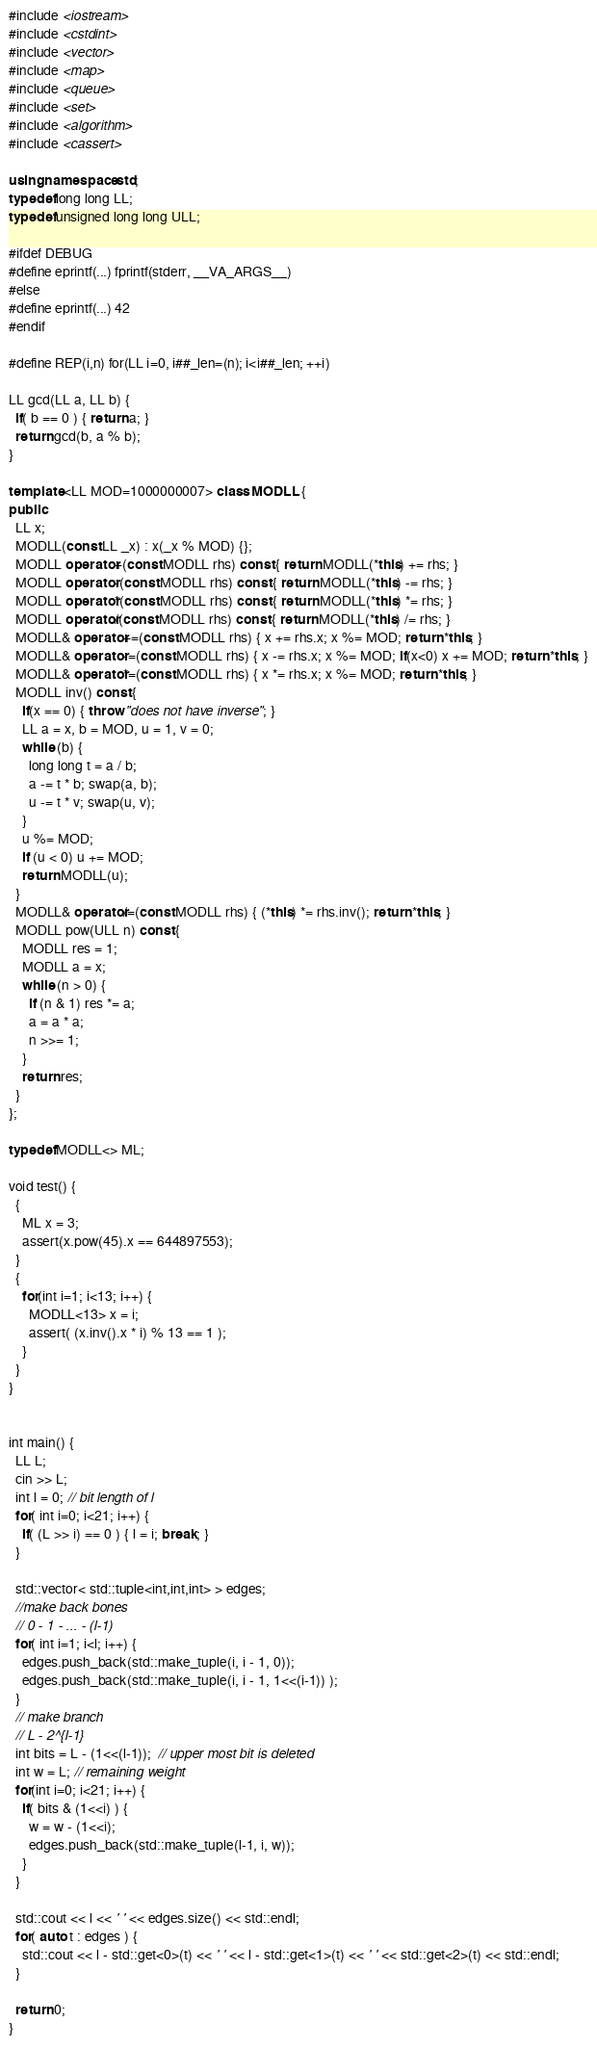<code> <loc_0><loc_0><loc_500><loc_500><_C++_>#include <iostream>
#include <cstdint>
#include <vector>
#include <map>
#include <queue>
#include <set>
#include <algorithm>
#include <cassert>

using namespace std;
typedef long long LL;
typedef unsigned long long ULL;

#ifdef DEBUG
#define eprintf(...) fprintf(stderr, __VA_ARGS__)
#else
#define eprintf(...) 42
#endif

#define REP(i,n) for(LL i=0, i##_len=(n); i<i##_len; ++i)

LL gcd(LL a, LL b) {
  if( b == 0 ) { return a; }
  return gcd(b, a % b);
}

template <LL MOD=1000000007> class MODLL {
public:
  LL x;
  MODLL(const LL _x) : x(_x % MOD) {};
  MODLL operator+(const MODLL rhs) const { return MODLL(*this) += rhs; }
  MODLL operator-(const MODLL rhs) const { return MODLL(*this) -= rhs; }
  MODLL operator*(const MODLL rhs) const { return MODLL(*this) *= rhs; }
  MODLL operator/(const MODLL rhs) const { return MODLL(*this) /= rhs; }
  MODLL& operator+=(const MODLL rhs) { x += rhs.x; x %= MOD; return *this; }
  MODLL& operator-=(const MODLL rhs) { x -= rhs.x; x %= MOD; if(x<0) x += MOD; return *this; }
  MODLL& operator*=(const MODLL rhs) { x *= rhs.x; x %= MOD; return *this; }
  MODLL inv() const {
    if(x == 0) { throw "does not have inverse"; }
    LL a = x, b = MOD, u = 1, v = 0;
    while (b) {
      long long t = a / b;
      a -= t * b; swap(a, b);
      u -= t * v; swap(u, v);
    }
    u %= MOD;
    if (u < 0) u += MOD;
    return MODLL(u);
  }
  MODLL& operator/=(const MODLL rhs) { (*this) *= rhs.inv(); return *this; }
  MODLL pow(ULL n) const {
    MODLL res = 1;
    MODLL a = x;
    while (n > 0) {
      if (n & 1) res *= a;
      a = a * a;
      n >>= 1;
    }
    return res;
  }
};

typedef MODLL<> ML;

void test() {
  {
    ML x = 3;
    assert(x.pow(45).x == 644897553);
  }
  {
    for(int i=1; i<13; i++) {
      MODLL<13> x = i;
      assert( (x.inv().x * i) % 13 == 1 );
    }
  }
}


int main() {
  LL L;
  cin >> L;
  int l = 0; // bit length of l
  for( int i=0; i<21; i++) {
    if( (L >> i) == 0 ) { l = i; break; }
  }

  std::vector< std::tuple<int,int,int> > edges;
  //make back bones
  // 0 - 1 - ... - (l-1)
  for( int i=1; i<l; i++) {
    edges.push_back(std::make_tuple(i, i - 1, 0));
    edges.push_back(std::make_tuple(i, i - 1, 1<<(i-1)) );
  }
  // make branch
  // L - 2^{l-1}
  int bits = L - (1<<(l-1));  // upper most bit is deleted
  int w = L; // remaining weight
  for(int i=0; i<21; i++) {
    if( bits & (1<<i) ) {
      w = w - (1<<i);
      edges.push_back(std::make_tuple(l-1, i, w));
    }
  }

  std::cout << l << ' ' << edges.size() << std::endl;
  for( auto t : edges ) {
    std::cout << l - std::get<0>(t) << ' ' << l - std::get<1>(t) << ' ' << std::get<2>(t) << std::endl;
  }

  return 0;
}

</code> 